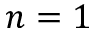Convert formula to latex. <formula><loc_0><loc_0><loc_500><loc_500>n = 1</formula> 